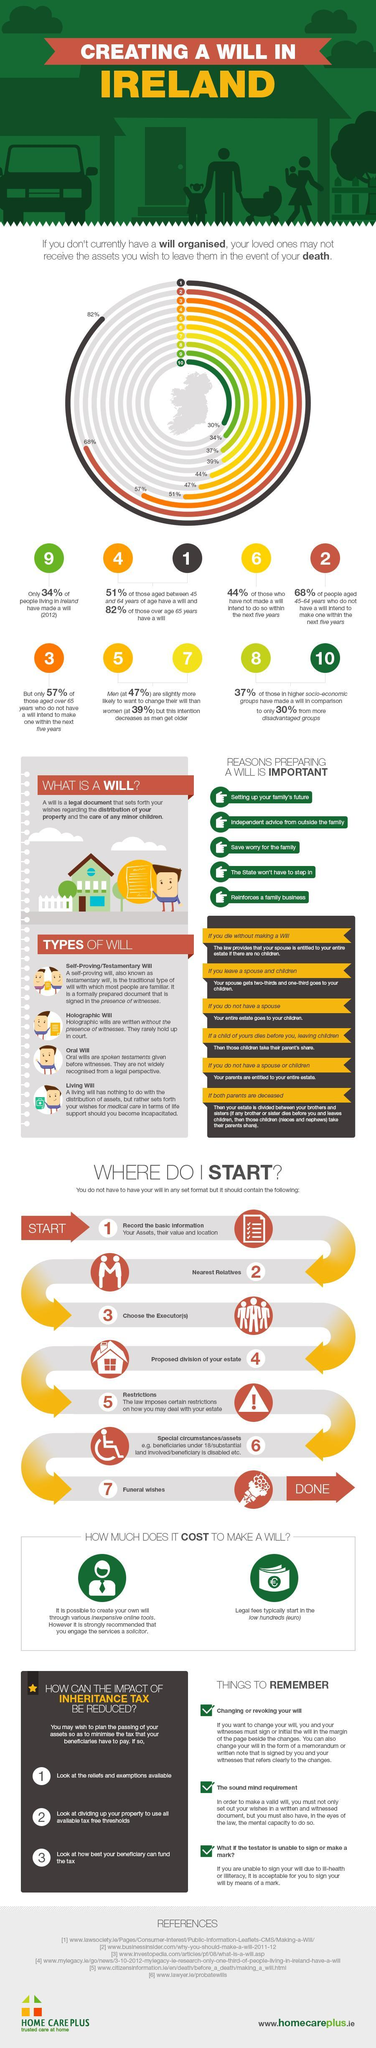What is listed third as a reason for preparing a will?
Answer the question with a short phrase. Save worry for the family In which case are parents entitled to your estate? If you do not have a spouse or children What tax do the beneficiaries have to pay? Inheritance tax 